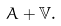<formula> <loc_0><loc_0><loc_500><loc_500>A + \mathbb { V } .</formula> 